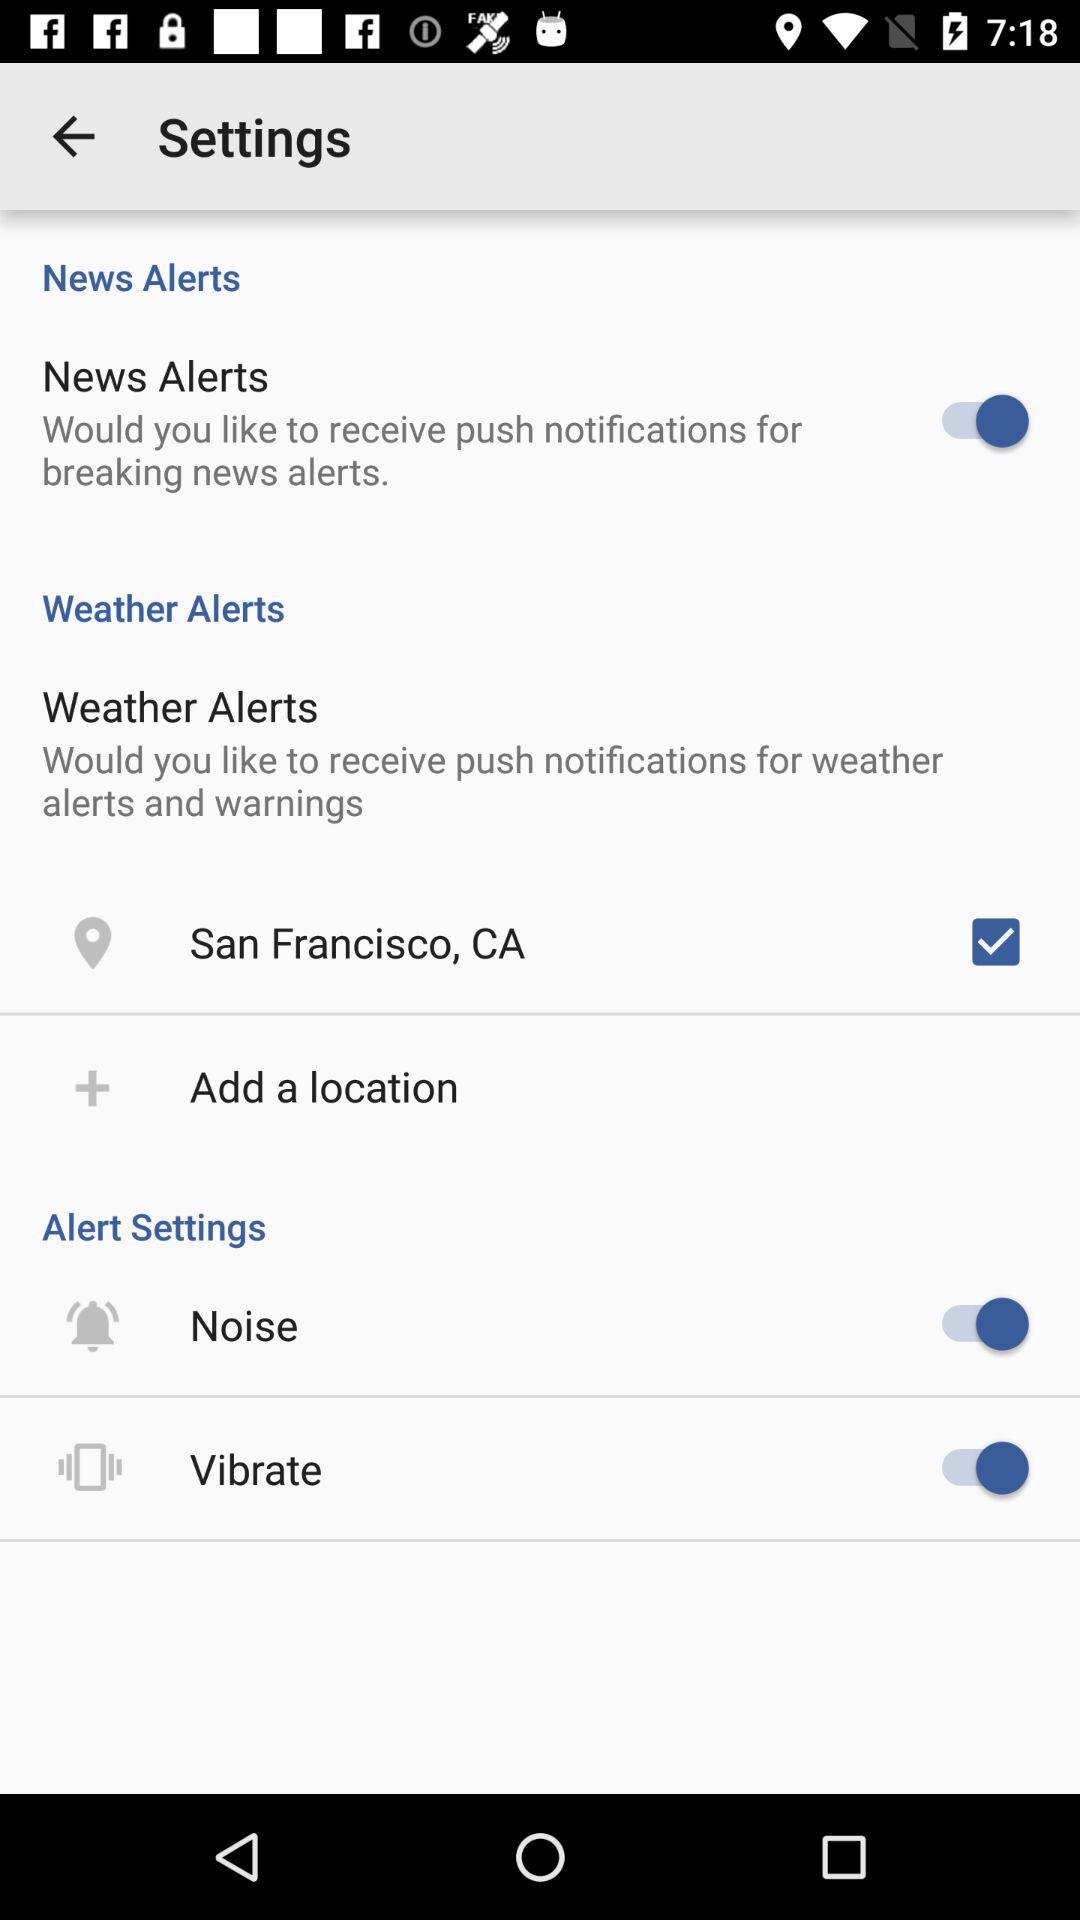What is the location? The location is San Francisco, CA. 